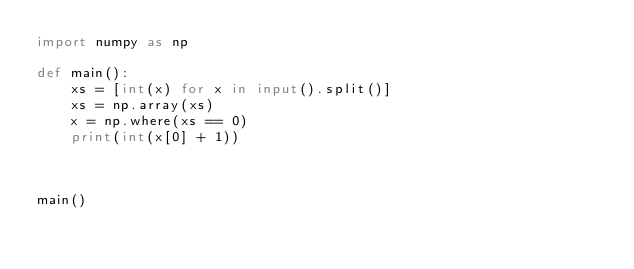Convert code to text. <code><loc_0><loc_0><loc_500><loc_500><_Python_>import numpy as np

def main():
    xs = [int(x) for x in input().split()]
    xs = np.array(xs)
    x = np.where(xs == 0)
    print(int(x[0] + 1))
    
    

main()
</code> 